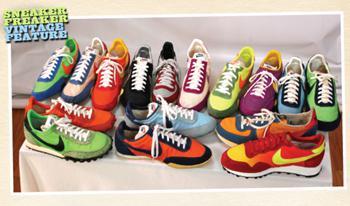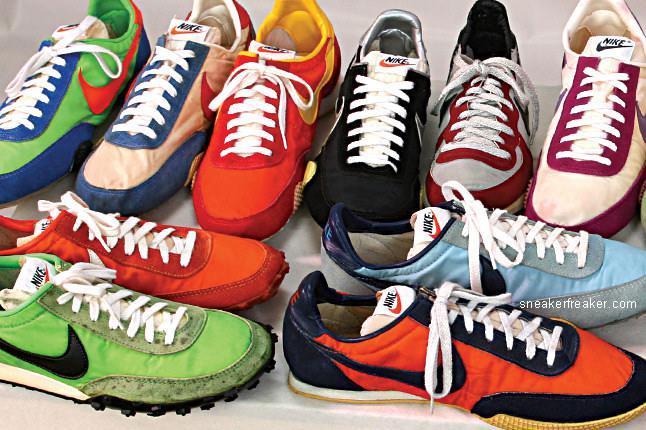The first image is the image on the left, the second image is the image on the right. Evaluate the accuracy of this statement regarding the images: "The left image contains no more than one shoe.". Is it true? Answer yes or no. No. The first image is the image on the left, the second image is the image on the right. Assess this claim about the two images: "Every shoe is posed facing directly leftward, and one image contains a single shoe.". Correct or not? Answer yes or no. No. 